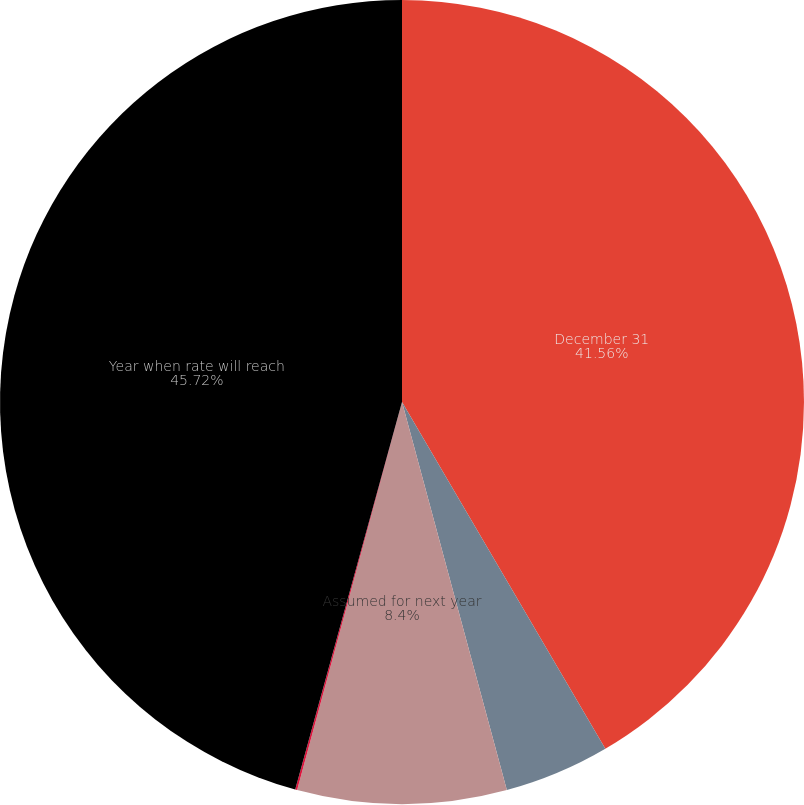Convert chart to OTSL. <chart><loc_0><loc_0><loc_500><loc_500><pie_chart><fcel>December 31<fcel>OPEB plans<fcel>Assumed for next year<fcel>Ultimate<fcel>Year when rate will reach<nl><fcel>41.56%<fcel>4.24%<fcel>8.4%<fcel>0.08%<fcel>45.72%<nl></chart> 